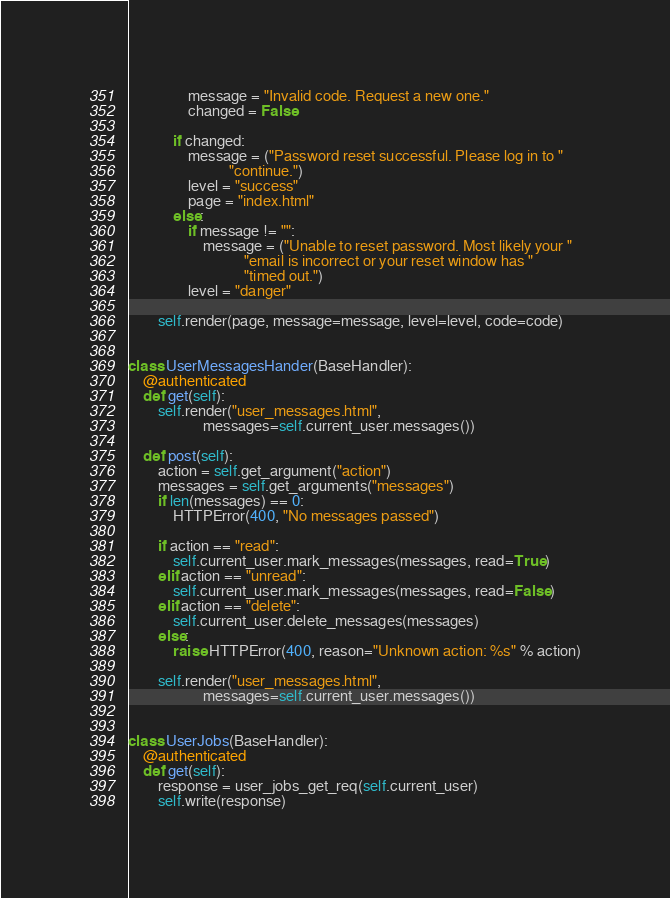<code> <loc_0><loc_0><loc_500><loc_500><_Python_>                message = "Invalid code. Request a new one."
                changed = False

            if changed:
                message = ("Password reset successful. Please log in to "
                           "continue.")
                level = "success"
                page = "index.html"
            else:
                if message != "":
                    message = ("Unable to reset password. Most likely your "
                               "email is incorrect or your reset window has "
                               "timed out.")
                level = "danger"

        self.render(page, message=message, level=level, code=code)


class UserMessagesHander(BaseHandler):
    @authenticated
    def get(self):
        self.render("user_messages.html",
                    messages=self.current_user.messages())

    def post(self):
        action = self.get_argument("action")
        messages = self.get_arguments("messages")
        if len(messages) == 0:
            HTTPError(400, "No messages passed")

        if action == "read":
            self.current_user.mark_messages(messages, read=True)
        elif action == "unread":
            self.current_user.mark_messages(messages, read=False)
        elif action == "delete":
            self.current_user.delete_messages(messages)
        else:
            raise HTTPError(400, reason="Unknown action: %s" % action)

        self.render("user_messages.html",
                    messages=self.current_user.messages())


class UserJobs(BaseHandler):
    @authenticated
    def get(self):
        response = user_jobs_get_req(self.current_user)
        self.write(response)
</code> 